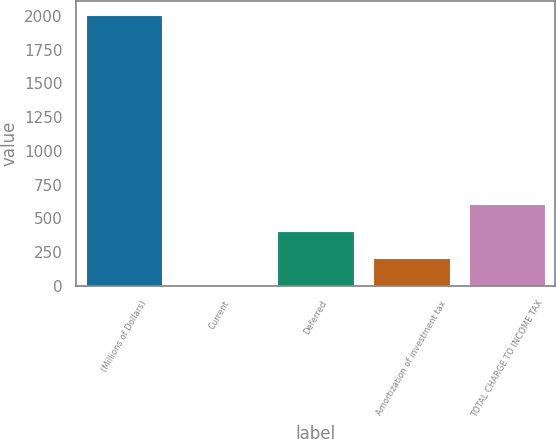<chart> <loc_0><loc_0><loc_500><loc_500><bar_chart><fcel>(Millions of Dollars)<fcel>Current<fcel>Deferred<fcel>Amortization of investment tax<fcel>TOTAL CHARGE TO INCOME TAX<nl><fcel>2009<fcel>1<fcel>402.6<fcel>201.8<fcel>603.4<nl></chart> 